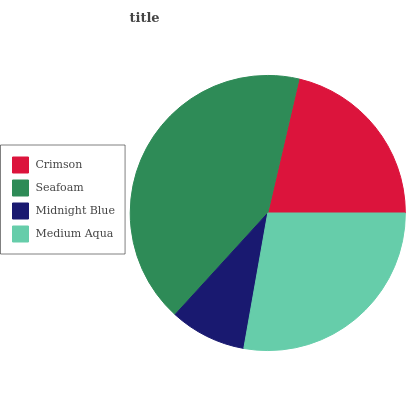Is Midnight Blue the minimum?
Answer yes or no. Yes. Is Seafoam the maximum?
Answer yes or no. Yes. Is Seafoam the minimum?
Answer yes or no. No. Is Midnight Blue the maximum?
Answer yes or no. No. Is Seafoam greater than Midnight Blue?
Answer yes or no. Yes. Is Midnight Blue less than Seafoam?
Answer yes or no. Yes. Is Midnight Blue greater than Seafoam?
Answer yes or no. No. Is Seafoam less than Midnight Blue?
Answer yes or no. No. Is Medium Aqua the high median?
Answer yes or no. Yes. Is Crimson the low median?
Answer yes or no. Yes. Is Midnight Blue the high median?
Answer yes or no. No. Is Midnight Blue the low median?
Answer yes or no. No. 